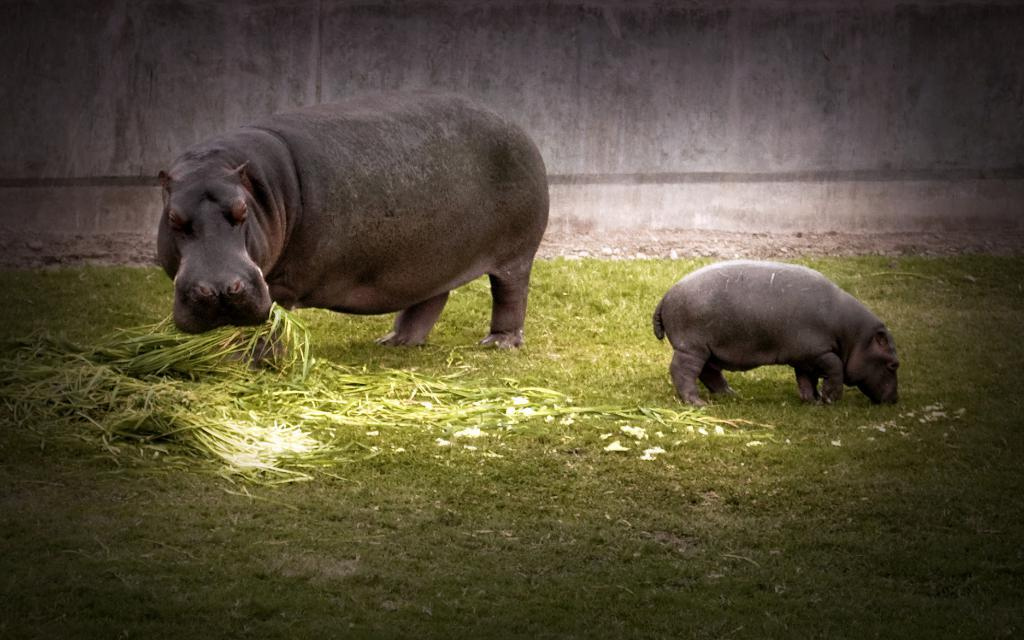How many animals are present in the image? There are two animals in the image. What is the position of the animals in the image? The animals are on the ground. What is one of the animals doing with its mouth? One of the animals is holding grass in its mouth. What type of action is the animal performing to shake the grass in the image? There is no indication in the image that the animal is performing any action to shake the grass, as it is simply holding the grass in its mouth. 